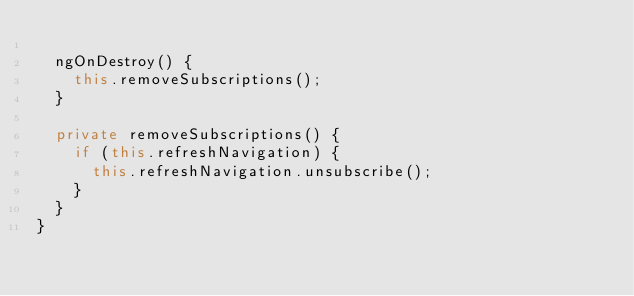Convert code to text. <code><loc_0><loc_0><loc_500><loc_500><_TypeScript_>
  ngOnDestroy() {
    this.removeSubscriptions();
  }

  private removeSubscriptions() {
    if (this.refreshNavigation) {
      this.refreshNavigation.unsubscribe();
    }
  }
}
</code> 